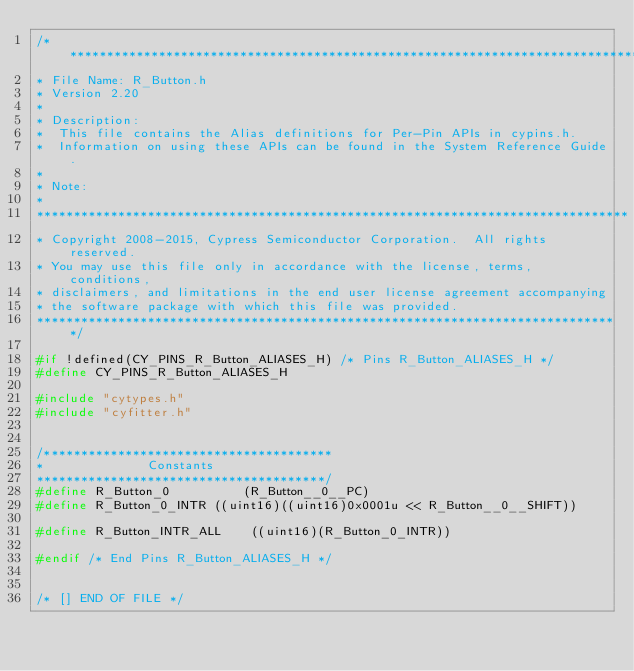<code> <loc_0><loc_0><loc_500><loc_500><_C_>/*******************************************************************************
* File Name: R_Button.h  
* Version 2.20
*
* Description:
*  This file contains the Alias definitions for Per-Pin APIs in cypins.h. 
*  Information on using these APIs can be found in the System Reference Guide.
*
* Note:
*
********************************************************************************
* Copyright 2008-2015, Cypress Semiconductor Corporation.  All rights reserved.
* You may use this file only in accordance with the license, terms, conditions, 
* disclaimers, and limitations in the end user license agreement accompanying 
* the software package with which this file was provided.
*******************************************************************************/

#if !defined(CY_PINS_R_Button_ALIASES_H) /* Pins R_Button_ALIASES_H */
#define CY_PINS_R_Button_ALIASES_H

#include "cytypes.h"
#include "cyfitter.h"


/***************************************
*              Constants        
***************************************/
#define R_Button_0			(R_Button__0__PC)
#define R_Button_0_INTR	((uint16)((uint16)0x0001u << R_Button__0__SHIFT))

#define R_Button_INTR_ALL	 ((uint16)(R_Button_0_INTR))

#endif /* End Pins R_Button_ALIASES_H */


/* [] END OF FILE */
</code> 